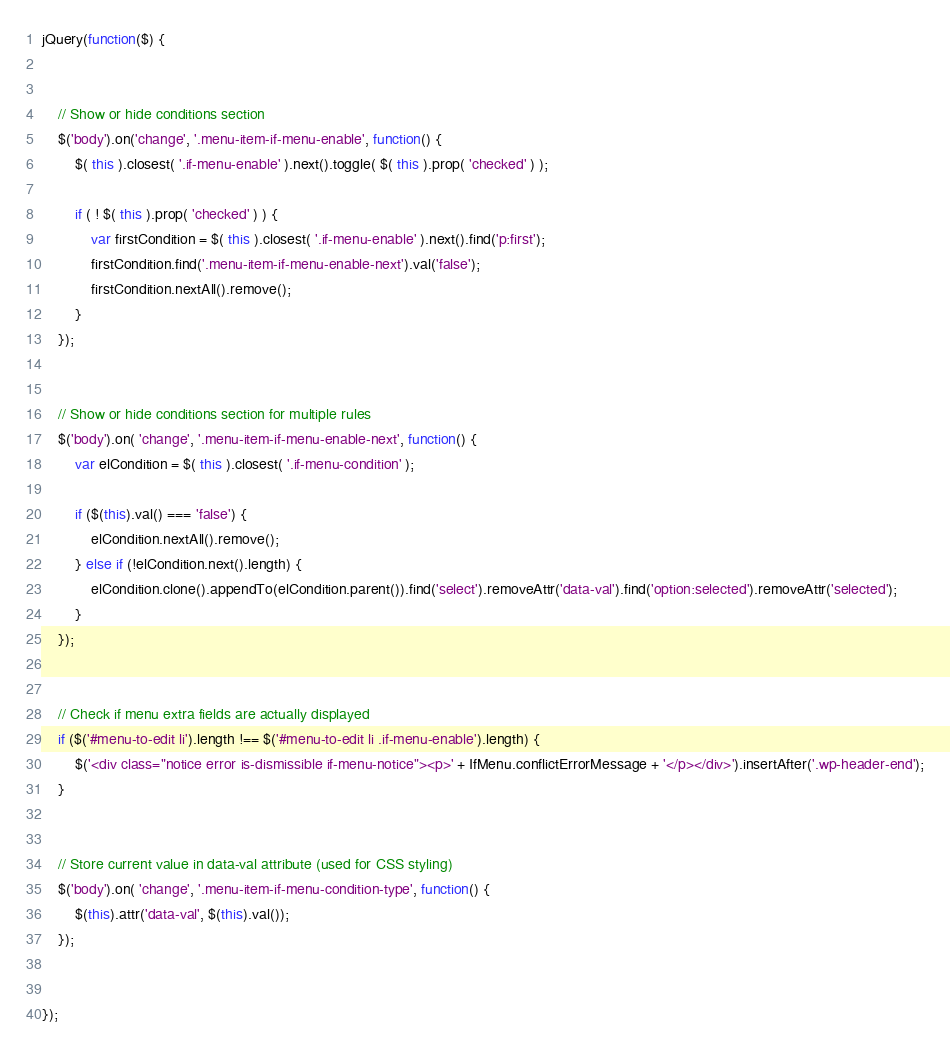Convert code to text. <code><loc_0><loc_0><loc_500><loc_500><_JavaScript_>jQuery(function($) {


	// Show or hide conditions section
	$('body').on('change', '.menu-item-if-menu-enable', function() {
		$( this ).closest( '.if-menu-enable' ).next().toggle( $( this ).prop( 'checked' ) );

		if ( ! $( this ).prop( 'checked' ) ) {
			var firstCondition = $( this ).closest( '.if-menu-enable' ).next().find('p:first');
			firstCondition.find('.menu-item-if-menu-enable-next').val('false');
			firstCondition.nextAll().remove();
		}
	});


	// Show or hide conditions section for multiple rules
	$('body').on( 'change', '.menu-item-if-menu-enable-next', function() {
		var elCondition = $( this ).closest( '.if-menu-condition' );

		if ($(this).val() === 'false') {
			elCondition.nextAll().remove();
		} else if (!elCondition.next().length) {
			elCondition.clone().appendTo(elCondition.parent()).find('select').removeAttr('data-val').find('option:selected').removeAttr('selected');
		}
	});


	// Check if menu extra fields are actually displayed
	if ($('#menu-to-edit li').length !== $('#menu-to-edit li .if-menu-enable').length) {
		$('<div class="notice error is-dismissible if-menu-notice"><p>' + IfMenu.conflictErrorMessage + '</p></div>').insertAfter('.wp-header-end');
	}


	// Store current value in data-val attribute (used for CSS styling)
	$('body').on( 'change', '.menu-item-if-menu-condition-type', function() {
		$(this).attr('data-val', $(this).val());
	});


});
</code> 